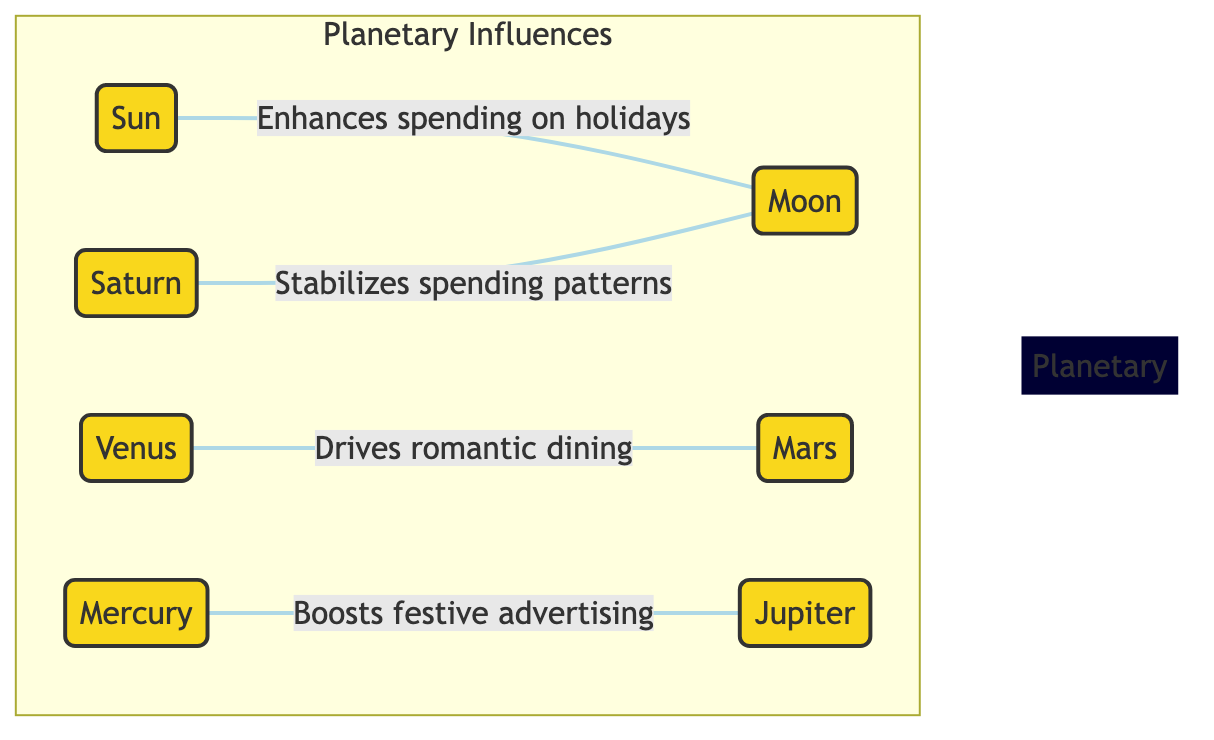What is the main influence of the Sun? The diagram indicates that the Sun enhances spending on holidays, connecting it directly to the Moon, showing its primary influence on holiday spending.
Answer: enhances spending on holidays How many planets are depicted in the diagram? The diagram lists seven distinct planets: the Sun, Moon, Mercury, Venus, Mars, Jupiter, and Saturn. Counting these gives the total of seven planets shown in the diagram.
Answer: seven Which planet is associated with romantic dining? The connection in the diagram shows that Venus drives romantic dining, indicating its specific influence in this area, which also involves Mars as connected in the relationship.
Answer: Venus What influences festive advertising? Mercury is shown in the diagram as boosting festive advertising, implying its specific role in promoting advertising during festive occasions, and it's connected to Jupiter in this context.
Answer: Mercury What is the relationship between Saturn and the Moon? The diagram illustrates that Saturn stabilizes spending patterns and has a direct connection to the Moon, implying that Saturn’s influence provides stability to spending that is enhanced by the Moon's effects.
Answer: stabilizes spending patterns 